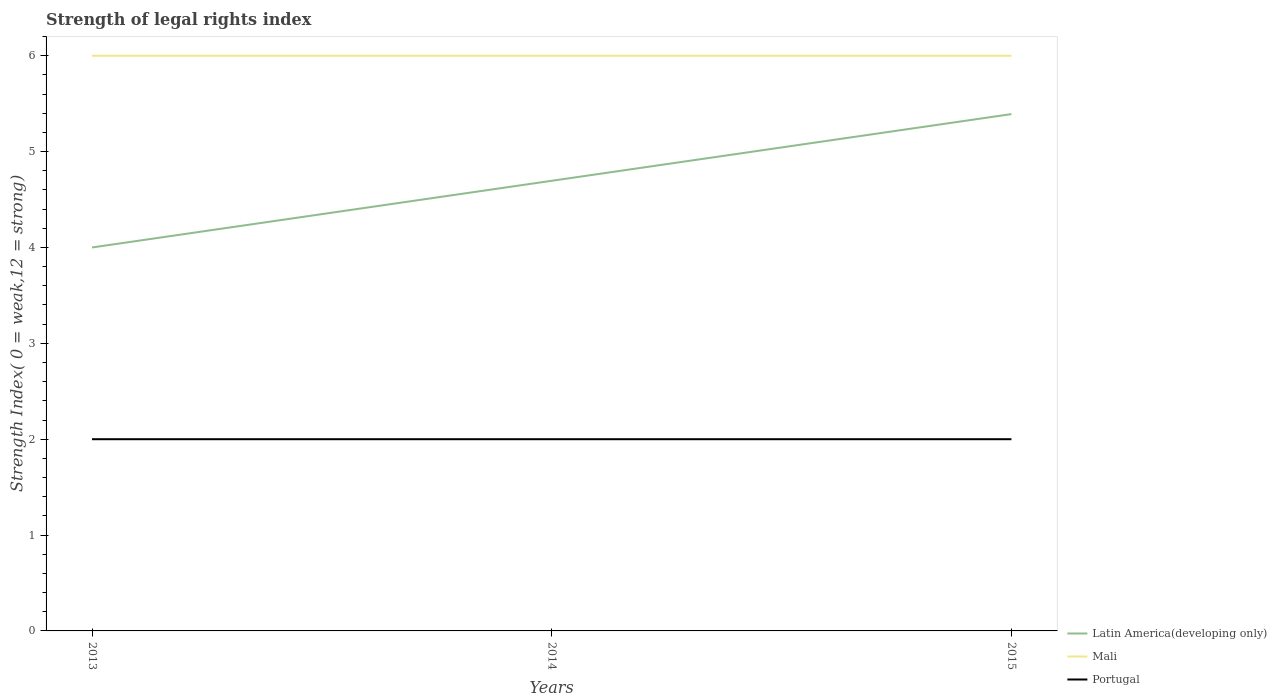How many different coloured lines are there?
Keep it short and to the point. 3. Across all years, what is the maximum strength index in Portugal?
Keep it short and to the point. 2. In which year was the strength index in Latin America(developing only) maximum?
Make the answer very short. 2013. What is the difference between the highest and the second highest strength index in Portugal?
Offer a very short reply. 0. What is the difference between two consecutive major ticks on the Y-axis?
Make the answer very short. 1. How are the legend labels stacked?
Give a very brief answer. Vertical. What is the title of the graph?
Ensure brevity in your answer.  Strength of legal rights index. What is the label or title of the X-axis?
Keep it short and to the point. Years. What is the label or title of the Y-axis?
Offer a terse response. Strength Index( 0 = weak,12 = strong). What is the Strength Index( 0 = weak,12 = strong) of Latin America(developing only) in 2013?
Your answer should be very brief. 4. What is the Strength Index( 0 = weak,12 = strong) in Mali in 2013?
Offer a terse response. 6. What is the Strength Index( 0 = weak,12 = strong) in Portugal in 2013?
Provide a succinct answer. 2. What is the Strength Index( 0 = weak,12 = strong) in Latin America(developing only) in 2014?
Keep it short and to the point. 4.7. What is the Strength Index( 0 = weak,12 = strong) in Portugal in 2014?
Give a very brief answer. 2. What is the Strength Index( 0 = weak,12 = strong) of Latin America(developing only) in 2015?
Your response must be concise. 5.39. What is the Strength Index( 0 = weak,12 = strong) in Mali in 2015?
Keep it short and to the point. 6. Across all years, what is the maximum Strength Index( 0 = weak,12 = strong) of Latin America(developing only)?
Make the answer very short. 5.39. Across all years, what is the maximum Strength Index( 0 = weak,12 = strong) in Mali?
Give a very brief answer. 6. Across all years, what is the maximum Strength Index( 0 = weak,12 = strong) of Portugal?
Ensure brevity in your answer.  2. Across all years, what is the minimum Strength Index( 0 = weak,12 = strong) of Latin America(developing only)?
Provide a short and direct response. 4. Across all years, what is the minimum Strength Index( 0 = weak,12 = strong) in Portugal?
Ensure brevity in your answer.  2. What is the total Strength Index( 0 = weak,12 = strong) in Latin America(developing only) in the graph?
Give a very brief answer. 14.09. What is the total Strength Index( 0 = weak,12 = strong) of Mali in the graph?
Your response must be concise. 18. What is the difference between the Strength Index( 0 = weak,12 = strong) of Latin America(developing only) in 2013 and that in 2014?
Your answer should be compact. -0.7. What is the difference between the Strength Index( 0 = weak,12 = strong) of Portugal in 2013 and that in 2014?
Offer a very short reply. 0. What is the difference between the Strength Index( 0 = weak,12 = strong) in Latin America(developing only) in 2013 and that in 2015?
Your response must be concise. -1.39. What is the difference between the Strength Index( 0 = weak,12 = strong) of Portugal in 2013 and that in 2015?
Your response must be concise. 0. What is the difference between the Strength Index( 0 = weak,12 = strong) of Latin America(developing only) in 2014 and that in 2015?
Your answer should be very brief. -0.7. What is the difference between the Strength Index( 0 = weak,12 = strong) of Portugal in 2014 and that in 2015?
Offer a very short reply. 0. What is the difference between the Strength Index( 0 = weak,12 = strong) in Mali in 2013 and the Strength Index( 0 = weak,12 = strong) in Portugal in 2014?
Your answer should be compact. 4. What is the difference between the Strength Index( 0 = weak,12 = strong) in Mali in 2013 and the Strength Index( 0 = weak,12 = strong) in Portugal in 2015?
Make the answer very short. 4. What is the difference between the Strength Index( 0 = weak,12 = strong) in Latin America(developing only) in 2014 and the Strength Index( 0 = weak,12 = strong) in Mali in 2015?
Give a very brief answer. -1.3. What is the difference between the Strength Index( 0 = weak,12 = strong) of Latin America(developing only) in 2014 and the Strength Index( 0 = weak,12 = strong) of Portugal in 2015?
Ensure brevity in your answer.  2.7. What is the difference between the Strength Index( 0 = weak,12 = strong) in Mali in 2014 and the Strength Index( 0 = weak,12 = strong) in Portugal in 2015?
Make the answer very short. 4. What is the average Strength Index( 0 = weak,12 = strong) of Latin America(developing only) per year?
Provide a succinct answer. 4.7. In the year 2013, what is the difference between the Strength Index( 0 = weak,12 = strong) of Latin America(developing only) and Strength Index( 0 = weak,12 = strong) of Mali?
Your answer should be compact. -2. In the year 2014, what is the difference between the Strength Index( 0 = weak,12 = strong) of Latin America(developing only) and Strength Index( 0 = weak,12 = strong) of Mali?
Make the answer very short. -1.3. In the year 2014, what is the difference between the Strength Index( 0 = weak,12 = strong) in Latin America(developing only) and Strength Index( 0 = weak,12 = strong) in Portugal?
Give a very brief answer. 2.7. In the year 2015, what is the difference between the Strength Index( 0 = weak,12 = strong) of Latin America(developing only) and Strength Index( 0 = weak,12 = strong) of Mali?
Ensure brevity in your answer.  -0.61. In the year 2015, what is the difference between the Strength Index( 0 = weak,12 = strong) of Latin America(developing only) and Strength Index( 0 = weak,12 = strong) of Portugal?
Your answer should be compact. 3.39. What is the ratio of the Strength Index( 0 = weak,12 = strong) in Latin America(developing only) in 2013 to that in 2014?
Ensure brevity in your answer.  0.85. What is the ratio of the Strength Index( 0 = weak,12 = strong) in Portugal in 2013 to that in 2014?
Your answer should be compact. 1. What is the ratio of the Strength Index( 0 = weak,12 = strong) in Latin America(developing only) in 2013 to that in 2015?
Offer a very short reply. 0.74. What is the ratio of the Strength Index( 0 = weak,12 = strong) of Latin America(developing only) in 2014 to that in 2015?
Make the answer very short. 0.87. What is the ratio of the Strength Index( 0 = weak,12 = strong) of Mali in 2014 to that in 2015?
Offer a terse response. 1. What is the difference between the highest and the second highest Strength Index( 0 = weak,12 = strong) in Latin America(developing only)?
Provide a short and direct response. 0.7. What is the difference between the highest and the second highest Strength Index( 0 = weak,12 = strong) of Mali?
Your answer should be compact. 0. What is the difference between the highest and the lowest Strength Index( 0 = weak,12 = strong) of Latin America(developing only)?
Your answer should be very brief. 1.39. What is the difference between the highest and the lowest Strength Index( 0 = weak,12 = strong) of Mali?
Offer a very short reply. 0. 